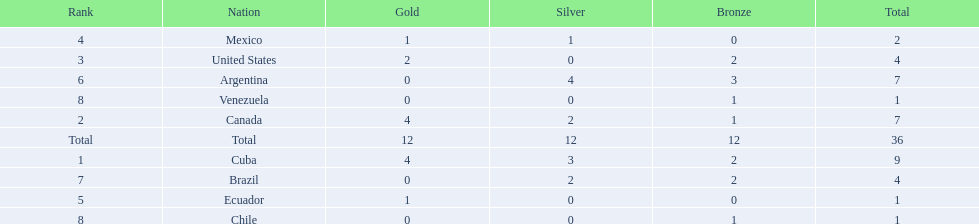What were the amounts of bronze medals won by the countries? 2, 1, 2, 0, 0, 3, 2, 1, 1. Which is the highest? 3. Which nation had this amount? Argentina. 